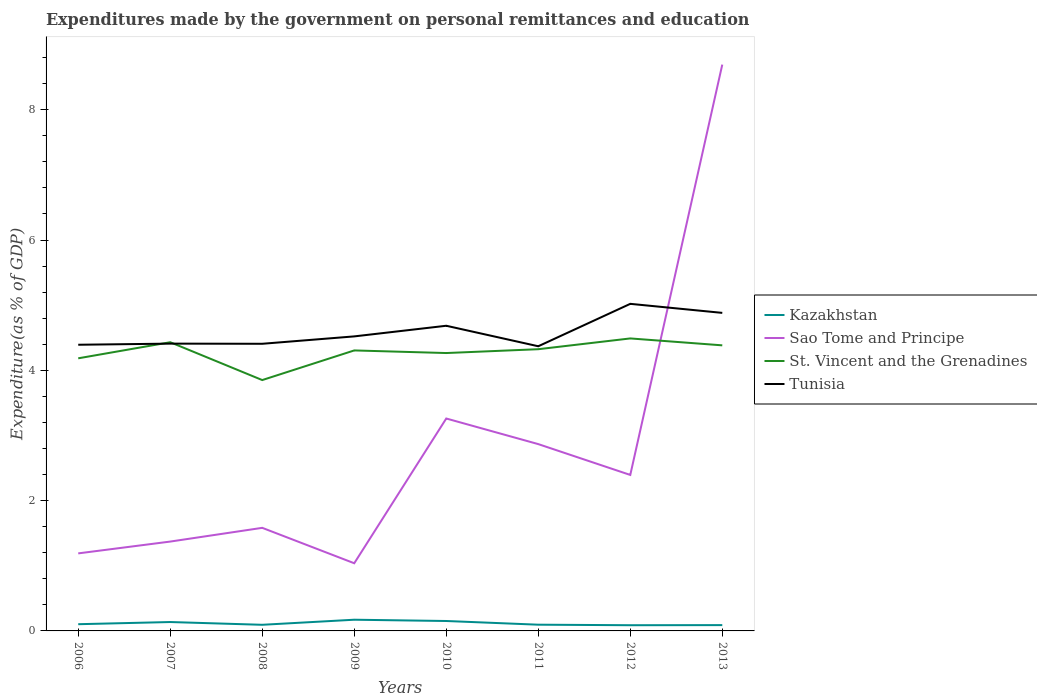How many different coloured lines are there?
Your answer should be very brief. 4. Does the line corresponding to Tunisia intersect with the line corresponding to Sao Tome and Principe?
Your response must be concise. Yes. Across all years, what is the maximum expenditures made by the government on personal remittances and education in Kazakhstan?
Ensure brevity in your answer.  0.09. In which year was the expenditures made by the government on personal remittances and education in St. Vincent and the Grenadines maximum?
Ensure brevity in your answer.  2008. What is the total expenditures made by the government on personal remittances and education in Kazakhstan in the graph?
Your answer should be compact. 0.04. What is the difference between the highest and the second highest expenditures made by the government on personal remittances and education in Kazakhstan?
Ensure brevity in your answer.  0.08. Is the expenditures made by the government on personal remittances and education in Tunisia strictly greater than the expenditures made by the government on personal remittances and education in Sao Tome and Principe over the years?
Ensure brevity in your answer.  No. How many lines are there?
Your response must be concise. 4. What is the difference between two consecutive major ticks on the Y-axis?
Keep it short and to the point. 2. Does the graph contain grids?
Provide a short and direct response. No. How many legend labels are there?
Your answer should be very brief. 4. How are the legend labels stacked?
Ensure brevity in your answer.  Vertical. What is the title of the graph?
Provide a short and direct response. Expenditures made by the government on personal remittances and education. Does "Namibia" appear as one of the legend labels in the graph?
Keep it short and to the point. No. What is the label or title of the X-axis?
Your answer should be very brief. Years. What is the label or title of the Y-axis?
Provide a succinct answer. Expenditure(as % of GDP). What is the Expenditure(as % of GDP) in Kazakhstan in 2006?
Offer a very short reply. 0.1. What is the Expenditure(as % of GDP) in Sao Tome and Principe in 2006?
Provide a succinct answer. 1.19. What is the Expenditure(as % of GDP) of St. Vincent and the Grenadines in 2006?
Give a very brief answer. 4.18. What is the Expenditure(as % of GDP) in Tunisia in 2006?
Make the answer very short. 4.39. What is the Expenditure(as % of GDP) of Kazakhstan in 2007?
Your response must be concise. 0.14. What is the Expenditure(as % of GDP) in Sao Tome and Principe in 2007?
Offer a terse response. 1.37. What is the Expenditure(as % of GDP) of St. Vincent and the Grenadines in 2007?
Your response must be concise. 4.43. What is the Expenditure(as % of GDP) of Tunisia in 2007?
Provide a succinct answer. 4.41. What is the Expenditure(as % of GDP) in Kazakhstan in 2008?
Your response must be concise. 0.09. What is the Expenditure(as % of GDP) in Sao Tome and Principe in 2008?
Offer a terse response. 1.58. What is the Expenditure(as % of GDP) in St. Vincent and the Grenadines in 2008?
Your answer should be compact. 3.85. What is the Expenditure(as % of GDP) in Tunisia in 2008?
Make the answer very short. 4.41. What is the Expenditure(as % of GDP) of Kazakhstan in 2009?
Your response must be concise. 0.17. What is the Expenditure(as % of GDP) of Sao Tome and Principe in 2009?
Give a very brief answer. 1.04. What is the Expenditure(as % of GDP) of St. Vincent and the Grenadines in 2009?
Offer a very short reply. 4.31. What is the Expenditure(as % of GDP) of Tunisia in 2009?
Give a very brief answer. 4.52. What is the Expenditure(as % of GDP) in Kazakhstan in 2010?
Your answer should be compact. 0.15. What is the Expenditure(as % of GDP) of Sao Tome and Principe in 2010?
Offer a very short reply. 3.26. What is the Expenditure(as % of GDP) in St. Vincent and the Grenadines in 2010?
Offer a very short reply. 4.27. What is the Expenditure(as % of GDP) in Tunisia in 2010?
Your answer should be very brief. 4.68. What is the Expenditure(as % of GDP) in Kazakhstan in 2011?
Keep it short and to the point. 0.1. What is the Expenditure(as % of GDP) in Sao Tome and Principe in 2011?
Your answer should be compact. 2.87. What is the Expenditure(as % of GDP) in St. Vincent and the Grenadines in 2011?
Your response must be concise. 4.32. What is the Expenditure(as % of GDP) in Tunisia in 2011?
Make the answer very short. 4.37. What is the Expenditure(as % of GDP) of Kazakhstan in 2012?
Provide a succinct answer. 0.09. What is the Expenditure(as % of GDP) of Sao Tome and Principe in 2012?
Keep it short and to the point. 2.39. What is the Expenditure(as % of GDP) in St. Vincent and the Grenadines in 2012?
Provide a succinct answer. 4.49. What is the Expenditure(as % of GDP) of Tunisia in 2012?
Offer a terse response. 5.02. What is the Expenditure(as % of GDP) of Kazakhstan in 2013?
Give a very brief answer. 0.09. What is the Expenditure(as % of GDP) of Sao Tome and Principe in 2013?
Your response must be concise. 8.69. What is the Expenditure(as % of GDP) of St. Vincent and the Grenadines in 2013?
Offer a very short reply. 4.38. What is the Expenditure(as % of GDP) in Tunisia in 2013?
Your answer should be very brief. 4.88. Across all years, what is the maximum Expenditure(as % of GDP) in Kazakhstan?
Your answer should be compact. 0.17. Across all years, what is the maximum Expenditure(as % of GDP) of Sao Tome and Principe?
Your answer should be very brief. 8.69. Across all years, what is the maximum Expenditure(as % of GDP) in St. Vincent and the Grenadines?
Make the answer very short. 4.49. Across all years, what is the maximum Expenditure(as % of GDP) in Tunisia?
Make the answer very short. 5.02. Across all years, what is the minimum Expenditure(as % of GDP) of Kazakhstan?
Keep it short and to the point. 0.09. Across all years, what is the minimum Expenditure(as % of GDP) in Sao Tome and Principe?
Your answer should be very brief. 1.04. Across all years, what is the minimum Expenditure(as % of GDP) in St. Vincent and the Grenadines?
Provide a short and direct response. 3.85. Across all years, what is the minimum Expenditure(as % of GDP) of Tunisia?
Your answer should be compact. 4.37. What is the total Expenditure(as % of GDP) of Kazakhstan in the graph?
Make the answer very short. 0.93. What is the total Expenditure(as % of GDP) in Sao Tome and Principe in the graph?
Ensure brevity in your answer.  22.4. What is the total Expenditure(as % of GDP) of St. Vincent and the Grenadines in the graph?
Keep it short and to the point. 34.23. What is the total Expenditure(as % of GDP) of Tunisia in the graph?
Your response must be concise. 36.69. What is the difference between the Expenditure(as % of GDP) in Kazakhstan in 2006 and that in 2007?
Your answer should be compact. -0.03. What is the difference between the Expenditure(as % of GDP) in Sao Tome and Principe in 2006 and that in 2007?
Provide a short and direct response. -0.18. What is the difference between the Expenditure(as % of GDP) in St. Vincent and the Grenadines in 2006 and that in 2007?
Keep it short and to the point. -0.25. What is the difference between the Expenditure(as % of GDP) in Tunisia in 2006 and that in 2007?
Offer a terse response. -0.02. What is the difference between the Expenditure(as % of GDP) of Kazakhstan in 2006 and that in 2008?
Ensure brevity in your answer.  0.01. What is the difference between the Expenditure(as % of GDP) in Sao Tome and Principe in 2006 and that in 2008?
Your response must be concise. -0.39. What is the difference between the Expenditure(as % of GDP) in St. Vincent and the Grenadines in 2006 and that in 2008?
Provide a short and direct response. 0.33. What is the difference between the Expenditure(as % of GDP) in Tunisia in 2006 and that in 2008?
Ensure brevity in your answer.  -0.01. What is the difference between the Expenditure(as % of GDP) of Kazakhstan in 2006 and that in 2009?
Your answer should be very brief. -0.07. What is the difference between the Expenditure(as % of GDP) of Sao Tome and Principe in 2006 and that in 2009?
Offer a terse response. 0.15. What is the difference between the Expenditure(as % of GDP) in St. Vincent and the Grenadines in 2006 and that in 2009?
Give a very brief answer. -0.12. What is the difference between the Expenditure(as % of GDP) of Tunisia in 2006 and that in 2009?
Offer a terse response. -0.13. What is the difference between the Expenditure(as % of GDP) of Kazakhstan in 2006 and that in 2010?
Provide a short and direct response. -0.05. What is the difference between the Expenditure(as % of GDP) of Sao Tome and Principe in 2006 and that in 2010?
Ensure brevity in your answer.  -2.07. What is the difference between the Expenditure(as % of GDP) of St. Vincent and the Grenadines in 2006 and that in 2010?
Your answer should be very brief. -0.08. What is the difference between the Expenditure(as % of GDP) of Tunisia in 2006 and that in 2010?
Ensure brevity in your answer.  -0.29. What is the difference between the Expenditure(as % of GDP) of Kazakhstan in 2006 and that in 2011?
Your response must be concise. 0.01. What is the difference between the Expenditure(as % of GDP) of Sao Tome and Principe in 2006 and that in 2011?
Give a very brief answer. -1.68. What is the difference between the Expenditure(as % of GDP) of St. Vincent and the Grenadines in 2006 and that in 2011?
Provide a succinct answer. -0.14. What is the difference between the Expenditure(as % of GDP) in Tunisia in 2006 and that in 2011?
Make the answer very short. 0.02. What is the difference between the Expenditure(as % of GDP) of Kazakhstan in 2006 and that in 2012?
Ensure brevity in your answer.  0.02. What is the difference between the Expenditure(as % of GDP) of Sao Tome and Principe in 2006 and that in 2012?
Offer a terse response. -1.2. What is the difference between the Expenditure(as % of GDP) of St. Vincent and the Grenadines in 2006 and that in 2012?
Your response must be concise. -0.31. What is the difference between the Expenditure(as % of GDP) in Tunisia in 2006 and that in 2012?
Provide a succinct answer. -0.63. What is the difference between the Expenditure(as % of GDP) of Kazakhstan in 2006 and that in 2013?
Ensure brevity in your answer.  0.01. What is the difference between the Expenditure(as % of GDP) in Sao Tome and Principe in 2006 and that in 2013?
Offer a terse response. -7.5. What is the difference between the Expenditure(as % of GDP) of St. Vincent and the Grenadines in 2006 and that in 2013?
Make the answer very short. -0.2. What is the difference between the Expenditure(as % of GDP) in Tunisia in 2006 and that in 2013?
Make the answer very short. -0.49. What is the difference between the Expenditure(as % of GDP) of Kazakhstan in 2007 and that in 2008?
Your answer should be compact. 0.04. What is the difference between the Expenditure(as % of GDP) in Sao Tome and Principe in 2007 and that in 2008?
Offer a very short reply. -0.21. What is the difference between the Expenditure(as % of GDP) of St. Vincent and the Grenadines in 2007 and that in 2008?
Make the answer very short. 0.58. What is the difference between the Expenditure(as % of GDP) in Tunisia in 2007 and that in 2008?
Offer a terse response. 0. What is the difference between the Expenditure(as % of GDP) of Kazakhstan in 2007 and that in 2009?
Offer a very short reply. -0.04. What is the difference between the Expenditure(as % of GDP) in Sao Tome and Principe in 2007 and that in 2009?
Provide a succinct answer. 0.33. What is the difference between the Expenditure(as % of GDP) of St. Vincent and the Grenadines in 2007 and that in 2009?
Ensure brevity in your answer.  0.13. What is the difference between the Expenditure(as % of GDP) in Tunisia in 2007 and that in 2009?
Keep it short and to the point. -0.11. What is the difference between the Expenditure(as % of GDP) in Kazakhstan in 2007 and that in 2010?
Offer a very short reply. -0.02. What is the difference between the Expenditure(as % of GDP) in Sao Tome and Principe in 2007 and that in 2010?
Provide a short and direct response. -1.89. What is the difference between the Expenditure(as % of GDP) in St. Vincent and the Grenadines in 2007 and that in 2010?
Offer a very short reply. 0.17. What is the difference between the Expenditure(as % of GDP) of Tunisia in 2007 and that in 2010?
Offer a very short reply. -0.27. What is the difference between the Expenditure(as % of GDP) in Kazakhstan in 2007 and that in 2011?
Your answer should be very brief. 0.04. What is the difference between the Expenditure(as % of GDP) in Sao Tome and Principe in 2007 and that in 2011?
Provide a succinct answer. -1.5. What is the difference between the Expenditure(as % of GDP) in St. Vincent and the Grenadines in 2007 and that in 2011?
Keep it short and to the point. 0.11. What is the difference between the Expenditure(as % of GDP) in Tunisia in 2007 and that in 2011?
Offer a terse response. 0.04. What is the difference between the Expenditure(as % of GDP) of Kazakhstan in 2007 and that in 2012?
Offer a terse response. 0.05. What is the difference between the Expenditure(as % of GDP) in Sao Tome and Principe in 2007 and that in 2012?
Your answer should be compact. -1.02. What is the difference between the Expenditure(as % of GDP) of St. Vincent and the Grenadines in 2007 and that in 2012?
Offer a terse response. -0.06. What is the difference between the Expenditure(as % of GDP) in Tunisia in 2007 and that in 2012?
Offer a very short reply. -0.61. What is the difference between the Expenditure(as % of GDP) in Kazakhstan in 2007 and that in 2013?
Provide a short and direct response. 0.05. What is the difference between the Expenditure(as % of GDP) of Sao Tome and Principe in 2007 and that in 2013?
Provide a short and direct response. -7.32. What is the difference between the Expenditure(as % of GDP) of St. Vincent and the Grenadines in 2007 and that in 2013?
Keep it short and to the point. 0.05. What is the difference between the Expenditure(as % of GDP) in Tunisia in 2007 and that in 2013?
Give a very brief answer. -0.47. What is the difference between the Expenditure(as % of GDP) in Kazakhstan in 2008 and that in 2009?
Your response must be concise. -0.08. What is the difference between the Expenditure(as % of GDP) in Sao Tome and Principe in 2008 and that in 2009?
Offer a terse response. 0.54. What is the difference between the Expenditure(as % of GDP) in St. Vincent and the Grenadines in 2008 and that in 2009?
Ensure brevity in your answer.  -0.45. What is the difference between the Expenditure(as % of GDP) of Tunisia in 2008 and that in 2009?
Ensure brevity in your answer.  -0.11. What is the difference between the Expenditure(as % of GDP) in Kazakhstan in 2008 and that in 2010?
Make the answer very short. -0.06. What is the difference between the Expenditure(as % of GDP) in Sao Tome and Principe in 2008 and that in 2010?
Your answer should be compact. -1.68. What is the difference between the Expenditure(as % of GDP) in St. Vincent and the Grenadines in 2008 and that in 2010?
Your answer should be very brief. -0.41. What is the difference between the Expenditure(as % of GDP) of Tunisia in 2008 and that in 2010?
Ensure brevity in your answer.  -0.28. What is the difference between the Expenditure(as % of GDP) in Kazakhstan in 2008 and that in 2011?
Your answer should be very brief. -0. What is the difference between the Expenditure(as % of GDP) in Sao Tome and Principe in 2008 and that in 2011?
Provide a succinct answer. -1.29. What is the difference between the Expenditure(as % of GDP) in St. Vincent and the Grenadines in 2008 and that in 2011?
Give a very brief answer. -0.47. What is the difference between the Expenditure(as % of GDP) of Tunisia in 2008 and that in 2011?
Provide a short and direct response. 0.04. What is the difference between the Expenditure(as % of GDP) in Kazakhstan in 2008 and that in 2012?
Ensure brevity in your answer.  0.01. What is the difference between the Expenditure(as % of GDP) of Sao Tome and Principe in 2008 and that in 2012?
Give a very brief answer. -0.81. What is the difference between the Expenditure(as % of GDP) in St. Vincent and the Grenadines in 2008 and that in 2012?
Provide a succinct answer. -0.64. What is the difference between the Expenditure(as % of GDP) in Tunisia in 2008 and that in 2012?
Your answer should be compact. -0.61. What is the difference between the Expenditure(as % of GDP) of Kazakhstan in 2008 and that in 2013?
Your answer should be compact. 0. What is the difference between the Expenditure(as % of GDP) of Sao Tome and Principe in 2008 and that in 2013?
Offer a terse response. -7.11. What is the difference between the Expenditure(as % of GDP) in St. Vincent and the Grenadines in 2008 and that in 2013?
Offer a very short reply. -0.53. What is the difference between the Expenditure(as % of GDP) of Tunisia in 2008 and that in 2013?
Offer a very short reply. -0.47. What is the difference between the Expenditure(as % of GDP) in Kazakhstan in 2009 and that in 2010?
Ensure brevity in your answer.  0.02. What is the difference between the Expenditure(as % of GDP) of Sao Tome and Principe in 2009 and that in 2010?
Your answer should be compact. -2.22. What is the difference between the Expenditure(as % of GDP) in St. Vincent and the Grenadines in 2009 and that in 2010?
Provide a succinct answer. 0.04. What is the difference between the Expenditure(as % of GDP) in Tunisia in 2009 and that in 2010?
Offer a terse response. -0.16. What is the difference between the Expenditure(as % of GDP) in Kazakhstan in 2009 and that in 2011?
Keep it short and to the point. 0.08. What is the difference between the Expenditure(as % of GDP) of Sao Tome and Principe in 2009 and that in 2011?
Your response must be concise. -1.83. What is the difference between the Expenditure(as % of GDP) in St. Vincent and the Grenadines in 2009 and that in 2011?
Offer a terse response. -0.02. What is the difference between the Expenditure(as % of GDP) in Tunisia in 2009 and that in 2011?
Provide a short and direct response. 0.15. What is the difference between the Expenditure(as % of GDP) of Kazakhstan in 2009 and that in 2012?
Provide a short and direct response. 0.08. What is the difference between the Expenditure(as % of GDP) of Sao Tome and Principe in 2009 and that in 2012?
Provide a succinct answer. -1.36. What is the difference between the Expenditure(as % of GDP) in St. Vincent and the Grenadines in 2009 and that in 2012?
Keep it short and to the point. -0.18. What is the difference between the Expenditure(as % of GDP) of Tunisia in 2009 and that in 2012?
Provide a short and direct response. -0.5. What is the difference between the Expenditure(as % of GDP) of Kazakhstan in 2009 and that in 2013?
Keep it short and to the point. 0.08. What is the difference between the Expenditure(as % of GDP) of Sao Tome and Principe in 2009 and that in 2013?
Make the answer very short. -7.65. What is the difference between the Expenditure(as % of GDP) in St. Vincent and the Grenadines in 2009 and that in 2013?
Your answer should be compact. -0.08. What is the difference between the Expenditure(as % of GDP) in Tunisia in 2009 and that in 2013?
Provide a short and direct response. -0.36. What is the difference between the Expenditure(as % of GDP) of Kazakhstan in 2010 and that in 2011?
Provide a short and direct response. 0.06. What is the difference between the Expenditure(as % of GDP) in Sao Tome and Principe in 2010 and that in 2011?
Offer a terse response. 0.39. What is the difference between the Expenditure(as % of GDP) of St. Vincent and the Grenadines in 2010 and that in 2011?
Ensure brevity in your answer.  -0.06. What is the difference between the Expenditure(as % of GDP) of Tunisia in 2010 and that in 2011?
Your response must be concise. 0.31. What is the difference between the Expenditure(as % of GDP) of Kazakhstan in 2010 and that in 2012?
Offer a very short reply. 0.06. What is the difference between the Expenditure(as % of GDP) in Sao Tome and Principe in 2010 and that in 2012?
Your answer should be compact. 0.87. What is the difference between the Expenditure(as % of GDP) of St. Vincent and the Grenadines in 2010 and that in 2012?
Offer a very short reply. -0.22. What is the difference between the Expenditure(as % of GDP) of Tunisia in 2010 and that in 2012?
Your answer should be very brief. -0.34. What is the difference between the Expenditure(as % of GDP) in Kazakhstan in 2010 and that in 2013?
Offer a terse response. 0.06. What is the difference between the Expenditure(as % of GDP) in Sao Tome and Principe in 2010 and that in 2013?
Provide a succinct answer. -5.43. What is the difference between the Expenditure(as % of GDP) in St. Vincent and the Grenadines in 2010 and that in 2013?
Offer a very short reply. -0.12. What is the difference between the Expenditure(as % of GDP) of Tunisia in 2010 and that in 2013?
Offer a terse response. -0.2. What is the difference between the Expenditure(as % of GDP) of Kazakhstan in 2011 and that in 2012?
Make the answer very short. 0.01. What is the difference between the Expenditure(as % of GDP) in Sao Tome and Principe in 2011 and that in 2012?
Offer a terse response. 0.47. What is the difference between the Expenditure(as % of GDP) of St. Vincent and the Grenadines in 2011 and that in 2012?
Your answer should be compact. -0.17. What is the difference between the Expenditure(as % of GDP) of Tunisia in 2011 and that in 2012?
Keep it short and to the point. -0.65. What is the difference between the Expenditure(as % of GDP) of Kazakhstan in 2011 and that in 2013?
Ensure brevity in your answer.  0.01. What is the difference between the Expenditure(as % of GDP) of Sao Tome and Principe in 2011 and that in 2013?
Keep it short and to the point. -5.83. What is the difference between the Expenditure(as % of GDP) in St. Vincent and the Grenadines in 2011 and that in 2013?
Give a very brief answer. -0.06. What is the difference between the Expenditure(as % of GDP) in Tunisia in 2011 and that in 2013?
Provide a short and direct response. -0.51. What is the difference between the Expenditure(as % of GDP) in Kazakhstan in 2012 and that in 2013?
Make the answer very short. -0. What is the difference between the Expenditure(as % of GDP) in Sao Tome and Principe in 2012 and that in 2013?
Your answer should be very brief. -6.3. What is the difference between the Expenditure(as % of GDP) in St. Vincent and the Grenadines in 2012 and that in 2013?
Offer a terse response. 0.11. What is the difference between the Expenditure(as % of GDP) in Tunisia in 2012 and that in 2013?
Your answer should be compact. 0.14. What is the difference between the Expenditure(as % of GDP) of Kazakhstan in 2006 and the Expenditure(as % of GDP) of Sao Tome and Principe in 2007?
Provide a short and direct response. -1.27. What is the difference between the Expenditure(as % of GDP) of Kazakhstan in 2006 and the Expenditure(as % of GDP) of St. Vincent and the Grenadines in 2007?
Give a very brief answer. -4.33. What is the difference between the Expenditure(as % of GDP) of Kazakhstan in 2006 and the Expenditure(as % of GDP) of Tunisia in 2007?
Provide a succinct answer. -4.31. What is the difference between the Expenditure(as % of GDP) of Sao Tome and Principe in 2006 and the Expenditure(as % of GDP) of St. Vincent and the Grenadines in 2007?
Provide a short and direct response. -3.24. What is the difference between the Expenditure(as % of GDP) of Sao Tome and Principe in 2006 and the Expenditure(as % of GDP) of Tunisia in 2007?
Provide a short and direct response. -3.22. What is the difference between the Expenditure(as % of GDP) of St. Vincent and the Grenadines in 2006 and the Expenditure(as % of GDP) of Tunisia in 2007?
Provide a short and direct response. -0.23. What is the difference between the Expenditure(as % of GDP) of Kazakhstan in 2006 and the Expenditure(as % of GDP) of Sao Tome and Principe in 2008?
Your response must be concise. -1.48. What is the difference between the Expenditure(as % of GDP) in Kazakhstan in 2006 and the Expenditure(as % of GDP) in St. Vincent and the Grenadines in 2008?
Your answer should be compact. -3.75. What is the difference between the Expenditure(as % of GDP) in Kazakhstan in 2006 and the Expenditure(as % of GDP) in Tunisia in 2008?
Provide a short and direct response. -4.3. What is the difference between the Expenditure(as % of GDP) of Sao Tome and Principe in 2006 and the Expenditure(as % of GDP) of St. Vincent and the Grenadines in 2008?
Ensure brevity in your answer.  -2.66. What is the difference between the Expenditure(as % of GDP) in Sao Tome and Principe in 2006 and the Expenditure(as % of GDP) in Tunisia in 2008?
Provide a succinct answer. -3.22. What is the difference between the Expenditure(as % of GDP) in St. Vincent and the Grenadines in 2006 and the Expenditure(as % of GDP) in Tunisia in 2008?
Give a very brief answer. -0.22. What is the difference between the Expenditure(as % of GDP) of Kazakhstan in 2006 and the Expenditure(as % of GDP) of Sao Tome and Principe in 2009?
Give a very brief answer. -0.94. What is the difference between the Expenditure(as % of GDP) of Kazakhstan in 2006 and the Expenditure(as % of GDP) of St. Vincent and the Grenadines in 2009?
Ensure brevity in your answer.  -4.2. What is the difference between the Expenditure(as % of GDP) of Kazakhstan in 2006 and the Expenditure(as % of GDP) of Tunisia in 2009?
Provide a succinct answer. -4.42. What is the difference between the Expenditure(as % of GDP) in Sao Tome and Principe in 2006 and the Expenditure(as % of GDP) in St. Vincent and the Grenadines in 2009?
Your answer should be very brief. -3.12. What is the difference between the Expenditure(as % of GDP) in Sao Tome and Principe in 2006 and the Expenditure(as % of GDP) in Tunisia in 2009?
Offer a very short reply. -3.33. What is the difference between the Expenditure(as % of GDP) in St. Vincent and the Grenadines in 2006 and the Expenditure(as % of GDP) in Tunisia in 2009?
Your response must be concise. -0.34. What is the difference between the Expenditure(as % of GDP) in Kazakhstan in 2006 and the Expenditure(as % of GDP) in Sao Tome and Principe in 2010?
Offer a terse response. -3.16. What is the difference between the Expenditure(as % of GDP) of Kazakhstan in 2006 and the Expenditure(as % of GDP) of St. Vincent and the Grenadines in 2010?
Make the answer very short. -4.16. What is the difference between the Expenditure(as % of GDP) in Kazakhstan in 2006 and the Expenditure(as % of GDP) in Tunisia in 2010?
Your answer should be compact. -4.58. What is the difference between the Expenditure(as % of GDP) in Sao Tome and Principe in 2006 and the Expenditure(as % of GDP) in St. Vincent and the Grenadines in 2010?
Keep it short and to the point. -3.08. What is the difference between the Expenditure(as % of GDP) of Sao Tome and Principe in 2006 and the Expenditure(as % of GDP) of Tunisia in 2010?
Make the answer very short. -3.49. What is the difference between the Expenditure(as % of GDP) in St. Vincent and the Grenadines in 2006 and the Expenditure(as % of GDP) in Tunisia in 2010?
Give a very brief answer. -0.5. What is the difference between the Expenditure(as % of GDP) in Kazakhstan in 2006 and the Expenditure(as % of GDP) in Sao Tome and Principe in 2011?
Offer a very short reply. -2.76. What is the difference between the Expenditure(as % of GDP) of Kazakhstan in 2006 and the Expenditure(as % of GDP) of St. Vincent and the Grenadines in 2011?
Your response must be concise. -4.22. What is the difference between the Expenditure(as % of GDP) of Kazakhstan in 2006 and the Expenditure(as % of GDP) of Tunisia in 2011?
Your response must be concise. -4.27. What is the difference between the Expenditure(as % of GDP) in Sao Tome and Principe in 2006 and the Expenditure(as % of GDP) in St. Vincent and the Grenadines in 2011?
Offer a terse response. -3.13. What is the difference between the Expenditure(as % of GDP) in Sao Tome and Principe in 2006 and the Expenditure(as % of GDP) in Tunisia in 2011?
Give a very brief answer. -3.18. What is the difference between the Expenditure(as % of GDP) of St. Vincent and the Grenadines in 2006 and the Expenditure(as % of GDP) of Tunisia in 2011?
Make the answer very short. -0.18. What is the difference between the Expenditure(as % of GDP) in Kazakhstan in 2006 and the Expenditure(as % of GDP) in Sao Tome and Principe in 2012?
Provide a short and direct response. -2.29. What is the difference between the Expenditure(as % of GDP) of Kazakhstan in 2006 and the Expenditure(as % of GDP) of St. Vincent and the Grenadines in 2012?
Your response must be concise. -4.39. What is the difference between the Expenditure(as % of GDP) in Kazakhstan in 2006 and the Expenditure(as % of GDP) in Tunisia in 2012?
Provide a succinct answer. -4.92. What is the difference between the Expenditure(as % of GDP) of Sao Tome and Principe in 2006 and the Expenditure(as % of GDP) of St. Vincent and the Grenadines in 2012?
Your answer should be compact. -3.3. What is the difference between the Expenditure(as % of GDP) of Sao Tome and Principe in 2006 and the Expenditure(as % of GDP) of Tunisia in 2012?
Ensure brevity in your answer.  -3.83. What is the difference between the Expenditure(as % of GDP) in St. Vincent and the Grenadines in 2006 and the Expenditure(as % of GDP) in Tunisia in 2012?
Ensure brevity in your answer.  -0.84. What is the difference between the Expenditure(as % of GDP) in Kazakhstan in 2006 and the Expenditure(as % of GDP) in Sao Tome and Principe in 2013?
Give a very brief answer. -8.59. What is the difference between the Expenditure(as % of GDP) of Kazakhstan in 2006 and the Expenditure(as % of GDP) of St. Vincent and the Grenadines in 2013?
Make the answer very short. -4.28. What is the difference between the Expenditure(as % of GDP) of Kazakhstan in 2006 and the Expenditure(as % of GDP) of Tunisia in 2013?
Your answer should be very brief. -4.78. What is the difference between the Expenditure(as % of GDP) in Sao Tome and Principe in 2006 and the Expenditure(as % of GDP) in St. Vincent and the Grenadines in 2013?
Ensure brevity in your answer.  -3.19. What is the difference between the Expenditure(as % of GDP) in Sao Tome and Principe in 2006 and the Expenditure(as % of GDP) in Tunisia in 2013?
Make the answer very short. -3.69. What is the difference between the Expenditure(as % of GDP) in St. Vincent and the Grenadines in 2006 and the Expenditure(as % of GDP) in Tunisia in 2013?
Offer a very short reply. -0.7. What is the difference between the Expenditure(as % of GDP) in Kazakhstan in 2007 and the Expenditure(as % of GDP) in Sao Tome and Principe in 2008?
Your answer should be very brief. -1.45. What is the difference between the Expenditure(as % of GDP) in Kazakhstan in 2007 and the Expenditure(as % of GDP) in St. Vincent and the Grenadines in 2008?
Make the answer very short. -3.71. What is the difference between the Expenditure(as % of GDP) of Kazakhstan in 2007 and the Expenditure(as % of GDP) of Tunisia in 2008?
Provide a succinct answer. -4.27. What is the difference between the Expenditure(as % of GDP) in Sao Tome and Principe in 2007 and the Expenditure(as % of GDP) in St. Vincent and the Grenadines in 2008?
Offer a terse response. -2.48. What is the difference between the Expenditure(as % of GDP) in Sao Tome and Principe in 2007 and the Expenditure(as % of GDP) in Tunisia in 2008?
Provide a short and direct response. -3.04. What is the difference between the Expenditure(as % of GDP) of St. Vincent and the Grenadines in 2007 and the Expenditure(as % of GDP) of Tunisia in 2008?
Give a very brief answer. 0.02. What is the difference between the Expenditure(as % of GDP) of Kazakhstan in 2007 and the Expenditure(as % of GDP) of Sao Tome and Principe in 2009?
Offer a very short reply. -0.9. What is the difference between the Expenditure(as % of GDP) of Kazakhstan in 2007 and the Expenditure(as % of GDP) of St. Vincent and the Grenadines in 2009?
Provide a succinct answer. -4.17. What is the difference between the Expenditure(as % of GDP) in Kazakhstan in 2007 and the Expenditure(as % of GDP) in Tunisia in 2009?
Provide a short and direct response. -4.38. What is the difference between the Expenditure(as % of GDP) in Sao Tome and Principe in 2007 and the Expenditure(as % of GDP) in St. Vincent and the Grenadines in 2009?
Ensure brevity in your answer.  -2.93. What is the difference between the Expenditure(as % of GDP) of Sao Tome and Principe in 2007 and the Expenditure(as % of GDP) of Tunisia in 2009?
Make the answer very short. -3.15. What is the difference between the Expenditure(as % of GDP) of St. Vincent and the Grenadines in 2007 and the Expenditure(as % of GDP) of Tunisia in 2009?
Ensure brevity in your answer.  -0.09. What is the difference between the Expenditure(as % of GDP) of Kazakhstan in 2007 and the Expenditure(as % of GDP) of Sao Tome and Principe in 2010?
Give a very brief answer. -3.12. What is the difference between the Expenditure(as % of GDP) of Kazakhstan in 2007 and the Expenditure(as % of GDP) of St. Vincent and the Grenadines in 2010?
Your answer should be compact. -4.13. What is the difference between the Expenditure(as % of GDP) of Kazakhstan in 2007 and the Expenditure(as % of GDP) of Tunisia in 2010?
Your answer should be very brief. -4.55. What is the difference between the Expenditure(as % of GDP) of Sao Tome and Principe in 2007 and the Expenditure(as % of GDP) of St. Vincent and the Grenadines in 2010?
Ensure brevity in your answer.  -2.89. What is the difference between the Expenditure(as % of GDP) of Sao Tome and Principe in 2007 and the Expenditure(as % of GDP) of Tunisia in 2010?
Offer a terse response. -3.31. What is the difference between the Expenditure(as % of GDP) in St. Vincent and the Grenadines in 2007 and the Expenditure(as % of GDP) in Tunisia in 2010?
Ensure brevity in your answer.  -0.25. What is the difference between the Expenditure(as % of GDP) of Kazakhstan in 2007 and the Expenditure(as % of GDP) of Sao Tome and Principe in 2011?
Your response must be concise. -2.73. What is the difference between the Expenditure(as % of GDP) in Kazakhstan in 2007 and the Expenditure(as % of GDP) in St. Vincent and the Grenadines in 2011?
Provide a succinct answer. -4.19. What is the difference between the Expenditure(as % of GDP) in Kazakhstan in 2007 and the Expenditure(as % of GDP) in Tunisia in 2011?
Your response must be concise. -4.23. What is the difference between the Expenditure(as % of GDP) of Sao Tome and Principe in 2007 and the Expenditure(as % of GDP) of St. Vincent and the Grenadines in 2011?
Your answer should be compact. -2.95. What is the difference between the Expenditure(as % of GDP) in Sao Tome and Principe in 2007 and the Expenditure(as % of GDP) in Tunisia in 2011?
Offer a very short reply. -3. What is the difference between the Expenditure(as % of GDP) in St. Vincent and the Grenadines in 2007 and the Expenditure(as % of GDP) in Tunisia in 2011?
Make the answer very short. 0.06. What is the difference between the Expenditure(as % of GDP) in Kazakhstan in 2007 and the Expenditure(as % of GDP) in Sao Tome and Principe in 2012?
Provide a short and direct response. -2.26. What is the difference between the Expenditure(as % of GDP) of Kazakhstan in 2007 and the Expenditure(as % of GDP) of St. Vincent and the Grenadines in 2012?
Provide a short and direct response. -4.35. What is the difference between the Expenditure(as % of GDP) in Kazakhstan in 2007 and the Expenditure(as % of GDP) in Tunisia in 2012?
Your answer should be very brief. -4.88. What is the difference between the Expenditure(as % of GDP) in Sao Tome and Principe in 2007 and the Expenditure(as % of GDP) in St. Vincent and the Grenadines in 2012?
Your answer should be very brief. -3.12. What is the difference between the Expenditure(as % of GDP) of Sao Tome and Principe in 2007 and the Expenditure(as % of GDP) of Tunisia in 2012?
Offer a very short reply. -3.65. What is the difference between the Expenditure(as % of GDP) in St. Vincent and the Grenadines in 2007 and the Expenditure(as % of GDP) in Tunisia in 2012?
Offer a very short reply. -0.59. What is the difference between the Expenditure(as % of GDP) in Kazakhstan in 2007 and the Expenditure(as % of GDP) in Sao Tome and Principe in 2013?
Your response must be concise. -8.56. What is the difference between the Expenditure(as % of GDP) in Kazakhstan in 2007 and the Expenditure(as % of GDP) in St. Vincent and the Grenadines in 2013?
Provide a succinct answer. -4.25. What is the difference between the Expenditure(as % of GDP) of Kazakhstan in 2007 and the Expenditure(as % of GDP) of Tunisia in 2013?
Your answer should be very brief. -4.75. What is the difference between the Expenditure(as % of GDP) in Sao Tome and Principe in 2007 and the Expenditure(as % of GDP) in St. Vincent and the Grenadines in 2013?
Offer a very short reply. -3.01. What is the difference between the Expenditure(as % of GDP) of Sao Tome and Principe in 2007 and the Expenditure(as % of GDP) of Tunisia in 2013?
Give a very brief answer. -3.51. What is the difference between the Expenditure(as % of GDP) of St. Vincent and the Grenadines in 2007 and the Expenditure(as % of GDP) of Tunisia in 2013?
Ensure brevity in your answer.  -0.45. What is the difference between the Expenditure(as % of GDP) of Kazakhstan in 2008 and the Expenditure(as % of GDP) of Sao Tome and Principe in 2009?
Provide a short and direct response. -0.94. What is the difference between the Expenditure(as % of GDP) in Kazakhstan in 2008 and the Expenditure(as % of GDP) in St. Vincent and the Grenadines in 2009?
Provide a succinct answer. -4.21. What is the difference between the Expenditure(as % of GDP) of Kazakhstan in 2008 and the Expenditure(as % of GDP) of Tunisia in 2009?
Keep it short and to the point. -4.43. What is the difference between the Expenditure(as % of GDP) of Sao Tome and Principe in 2008 and the Expenditure(as % of GDP) of St. Vincent and the Grenadines in 2009?
Your answer should be compact. -2.72. What is the difference between the Expenditure(as % of GDP) of Sao Tome and Principe in 2008 and the Expenditure(as % of GDP) of Tunisia in 2009?
Your answer should be compact. -2.94. What is the difference between the Expenditure(as % of GDP) in St. Vincent and the Grenadines in 2008 and the Expenditure(as % of GDP) in Tunisia in 2009?
Your answer should be very brief. -0.67. What is the difference between the Expenditure(as % of GDP) in Kazakhstan in 2008 and the Expenditure(as % of GDP) in Sao Tome and Principe in 2010?
Keep it short and to the point. -3.17. What is the difference between the Expenditure(as % of GDP) of Kazakhstan in 2008 and the Expenditure(as % of GDP) of St. Vincent and the Grenadines in 2010?
Your response must be concise. -4.17. What is the difference between the Expenditure(as % of GDP) in Kazakhstan in 2008 and the Expenditure(as % of GDP) in Tunisia in 2010?
Offer a very short reply. -4.59. What is the difference between the Expenditure(as % of GDP) of Sao Tome and Principe in 2008 and the Expenditure(as % of GDP) of St. Vincent and the Grenadines in 2010?
Provide a succinct answer. -2.68. What is the difference between the Expenditure(as % of GDP) in Sao Tome and Principe in 2008 and the Expenditure(as % of GDP) in Tunisia in 2010?
Provide a succinct answer. -3.1. What is the difference between the Expenditure(as % of GDP) of St. Vincent and the Grenadines in 2008 and the Expenditure(as % of GDP) of Tunisia in 2010?
Provide a succinct answer. -0.83. What is the difference between the Expenditure(as % of GDP) in Kazakhstan in 2008 and the Expenditure(as % of GDP) in Sao Tome and Principe in 2011?
Ensure brevity in your answer.  -2.77. What is the difference between the Expenditure(as % of GDP) of Kazakhstan in 2008 and the Expenditure(as % of GDP) of St. Vincent and the Grenadines in 2011?
Offer a terse response. -4.23. What is the difference between the Expenditure(as % of GDP) of Kazakhstan in 2008 and the Expenditure(as % of GDP) of Tunisia in 2011?
Provide a succinct answer. -4.28. What is the difference between the Expenditure(as % of GDP) in Sao Tome and Principe in 2008 and the Expenditure(as % of GDP) in St. Vincent and the Grenadines in 2011?
Your answer should be very brief. -2.74. What is the difference between the Expenditure(as % of GDP) in Sao Tome and Principe in 2008 and the Expenditure(as % of GDP) in Tunisia in 2011?
Your response must be concise. -2.79. What is the difference between the Expenditure(as % of GDP) of St. Vincent and the Grenadines in 2008 and the Expenditure(as % of GDP) of Tunisia in 2011?
Your response must be concise. -0.52. What is the difference between the Expenditure(as % of GDP) in Kazakhstan in 2008 and the Expenditure(as % of GDP) in Sao Tome and Principe in 2012?
Your answer should be compact. -2.3. What is the difference between the Expenditure(as % of GDP) of Kazakhstan in 2008 and the Expenditure(as % of GDP) of St. Vincent and the Grenadines in 2012?
Give a very brief answer. -4.4. What is the difference between the Expenditure(as % of GDP) in Kazakhstan in 2008 and the Expenditure(as % of GDP) in Tunisia in 2012?
Give a very brief answer. -4.93. What is the difference between the Expenditure(as % of GDP) of Sao Tome and Principe in 2008 and the Expenditure(as % of GDP) of St. Vincent and the Grenadines in 2012?
Offer a very short reply. -2.91. What is the difference between the Expenditure(as % of GDP) in Sao Tome and Principe in 2008 and the Expenditure(as % of GDP) in Tunisia in 2012?
Your answer should be compact. -3.44. What is the difference between the Expenditure(as % of GDP) of St. Vincent and the Grenadines in 2008 and the Expenditure(as % of GDP) of Tunisia in 2012?
Your answer should be compact. -1.17. What is the difference between the Expenditure(as % of GDP) in Kazakhstan in 2008 and the Expenditure(as % of GDP) in Sao Tome and Principe in 2013?
Offer a terse response. -8.6. What is the difference between the Expenditure(as % of GDP) of Kazakhstan in 2008 and the Expenditure(as % of GDP) of St. Vincent and the Grenadines in 2013?
Ensure brevity in your answer.  -4.29. What is the difference between the Expenditure(as % of GDP) of Kazakhstan in 2008 and the Expenditure(as % of GDP) of Tunisia in 2013?
Offer a very short reply. -4.79. What is the difference between the Expenditure(as % of GDP) in Sao Tome and Principe in 2008 and the Expenditure(as % of GDP) in St. Vincent and the Grenadines in 2013?
Your answer should be very brief. -2.8. What is the difference between the Expenditure(as % of GDP) in Sao Tome and Principe in 2008 and the Expenditure(as % of GDP) in Tunisia in 2013?
Your answer should be compact. -3.3. What is the difference between the Expenditure(as % of GDP) of St. Vincent and the Grenadines in 2008 and the Expenditure(as % of GDP) of Tunisia in 2013?
Your response must be concise. -1.03. What is the difference between the Expenditure(as % of GDP) of Kazakhstan in 2009 and the Expenditure(as % of GDP) of Sao Tome and Principe in 2010?
Your answer should be very brief. -3.09. What is the difference between the Expenditure(as % of GDP) in Kazakhstan in 2009 and the Expenditure(as % of GDP) in St. Vincent and the Grenadines in 2010?
Provide a succinct answer. -4.09. What is the difference between the Expenditure(as % of GDP) in Kazakhstan in 2009 and the Expenditure(as % of GDP) in Tunisia in 2010?
Provide a succinct answer. -4.51. What is the difference between the Expenditure(as % of GDP) of Sao Tome and Principe in 2009 and the Expenditure(as % of GDP) of St. Vincent and the Grenadines in 2010?
Provide a short and direct response. -3.23. What is the difference between the Expenditure(as % of GDP) of Sao Tome and Principe in 2009 and the Expenditure(as % of GDP) of Tunisia in 2010?
Provide a short and direct response. -3.65. What is the difference between the Expenditure(as % of GDP) in St. Vincent and the Grenadines in 2009 and the Expenditure(as % of GDP) in Tunisia in 2010?
Ensure brevity in your answer.  -0.38. What is the difference between the Expenditure(as % of GDP) in Kazakhstan in 2009 and the Expenditure(as % of GDP) in Sao Tome and Principe in 2011?
Keep it short and to the point. -2.7. What is the difference between the Expenditure(as % of GDP) of Kazakhstan in 2009 and the Expenditure(as % of GDP) of St. Vincent and the Grenadines in 2011?
Ensure brevity in your answer.  -4.15. What is the difference between the Expenditure(as % of GDP) in Kazakhstan in 2009 and the Expenditure(as % of GDP) in Tunisia in 2011?
Offer a very short reply. -4.2. What is the difference between the Expenditure(as % of GDP) in Sao Tome and Principe in 2009 and the Expenditure(as % of GDP) in St. Vincent and the Grenadines in 2011?
Keep it short and to the point. -3.29. What is the difference between the Expenditure(as % of GDP) of Sao Tome and Principe in 2009 and the Expenditure(as % of GDP) of Tunisia in 2011?
Your answer should be very brief. -3.33. What is the difference between the Expenditure(as % of GDP) of St. Vincent and the Grenadines in 2009 and the Expenditure(as % of GDP) of Tunisia in 2011?
Offer a very short reply. -0.06. What is the difference between the Expenditure(as % of GDP) in Kazakhstan in 2009 and the Expenditure(as % of GDP) in Sao Tome and Principe in 2012?
Offer a very short reply. -2.22. What is the difference between the Expenditure(as % of GDP) in Kazakhstan in 2009 and the Expenditure(as % of GDP) in St. Vincent and the Grenadines in 2012?
Ensure brevity in your answer.  -4.32. What is the difference between the Expenditure(as % of GDP) of Kazakhstan in 2009 and the Expenditure(as % of GDP) of Tunisia in 2012?
Provide a succinct answer. -4.85. What is the difference between the Expenditure(as % of GDP) in Sao Tome and Principe in 2009 and the Expenditure(as % of GDP) in St. Vincent and the Grenadines in 2012?
Keep it short and to the point. -3.45. What is the difference between the Expenditure(as % of GDP) in Sao Tome and Principe in 2009 and the Expenditure(as % of GDP) in Tunisia in 2012?
Offer a very short reply. -3.98. What is the difference between the Expenditure(as % of GDP) of St. Vincent and the Grenadines in 2009 and the Expenditure(as % of GDP) of Tunisia in 2012?
Provide a succinct answer. -0.71. What is the difference between the Expenditure(as % of GDP) in Kazakhstan in 2009 and the Expenditure(as % of GDP) in Sao Tome and Principe in 2013?
Keep it short and to the point. -8.52. What is the difference between the Expenditure(as % of GDP) of Kazakhstan in 2009 and the Expenditure(as % of GDP) of St. Vincent and the Grenadines in 2013?
Ensure brevity in your answer.  -4.21. What is the difference between the Expenditure(as % of GDP) of Kazakhstan in 2009 and the Expenditure(as % of GDP) of Tunisia in 2013?
Provide a succinct answer. -4.71. What is the difference between the Expenditure(as % of GDP) in Sao Tome and Principe in 2009 and the Expenditure(as % of GDP) in St. Vincent and the Grenadines in 2013?
Ensure brevity in your answer.  -3.34. What is the difference between the Expenditure(as % of GDP) of Sao Tome and Principe in 2009 and the Expenditure(as % of GDP) of Tunisia in 2013?
Your response must be concise. -3.84. What is the difference between the Expenditure(as % of GDP) of St. Vincent and the Grenadines in 2009 and the Expenditure(as % of GDP) of Tunisia in 2013?
Make the answer very short. -0.58. What is the difference between the Expenditure(as % of GDP) of Kazakhstan in 2010 and the Expenditure(as % of GDP) of Sao Tome and Principe in 2011?
Provide a succinct answer. -2.71. What is the difference between the Expenditure(as % of GDP) in Kazakhstan in 2010 and the Expenditure(as % of GDP) in St. Vincent and the Grenadines in 2011?
Offer a terse response. -4.17. What is the difference between the Expenditure(as % of GDP) in Kazakhstan in 2010 and the Expenditure(as % of GDP) in Tunisia in 2011?
Offer a very short reply. -4.22. What is the difference between the Expenditure(as % of GDP) of Sao Tome and Principe in 2010 and the Expenditure(as % of GDP) of St. Vincent and the Grenadines in 2011?
Your response must be concise. -1.06. What is the difference between the Expenditure(as % of GDP) in Sao Tome and Principe in 2010 and the Expenditure(as % of GDP) in Tunisia in 2011?
Offer a terse response. -1.11. What is the difference between the Expenditure(as % of GDP) of St. Vincent and the Grenadines in 2010 and the Expenditure(as % of GDP) of Tunisia in 2011?
Give a very brief answer. -0.1. What is the difference between the Expenditure(as % of GDP) in Kazakhstan in 2010 and the Expenditure(as % of GDP) in Sao Tome and Principe in 2012?
Your answer should be compact. -2.24. What is the difference between the Expenditure(as % of GDP) in Kazakhstan in 2010 and the Expenditure(as % of GDP) in St. Vincent and the Grenadines in 2012?
Provide a succinct answer. -4.34. What is the difference between the Expenditure(as % of GDP) of Kazakhstan in 2010 and the Expenditure(as % of GDP) of Tunisia in 2012?
Your answer should be compact. -4.87. What is the difference between the Expenditure(as % of GDP) in Sao Tome and Principe in 2010 and the Expenditure(as % of GDP) in St. Vincent and the Grenadines in 2012?
Offer a terse response. -1.23. What is the difference between the Expenditure(as % of GDP) of Sao Tome and Principe in 2010 and the Expenditure(as % of GDP) of Tunisia in 2012?
Keep it short and to the point. -1.76. What is the difference between the Expenditure(as % of GDP) in St. Vincent and the Grenadines in 2010 and the Expenditure(as % of GDP) in Tunisia in 2012?
Give a very brief answer. -0.76. What is the difference between the Expenditure(as % of GDP) of Kazakhstan in 2010 and the Expenditure(as % of GDP) of Sao Tome and Principe in 2013?
Offer a terse response. -8.54. What is the difference between the Expenditure(as % of GDP) in Kazakhstan in 2010 and the Expenditure(as % of GDP) in St. Vincent and the Grenadines in 2013?
Offer a terse response. -4.23. What is the difference between the Expenditure(as % of GDP) of Kazakhstan in 2010 and the Expenditure(as % of GDP) of Tunisia in 2013?
Your answer should be very brief. -4.73. What is the difference between the Expenditure(as % of GDP) of Sao Tome and Principe in 2010 and the Expenditure(as % of GDP) of St. Vincent and the Grenadines in 2013?
Ensure brevity in your answer.  -1.12. What is the difference between the Expenditure(as % of GDP) of Sao Tome and Principe in 2010 and the Expenditure(as % of GDP) of Tunisia in 2013?
Your response must be concise. -1.62. What is the difference between the Expenditure(as % of GDP) of St. Vincent and the Grenadines in 2010 and the Expenditure(as % of GDP) of Tunisia in 2013?
Your response must be concise. -0.62. What is the difference between the Expenditure(as % of GDP) of Kazakhstan in 2011 and the Expenditure(as % of GDP) of Sao Tome and Principe in 2012?
Offer a terse response. -2.3. What is the difference between the Expenditure(as % of GDP) in Kazakhstan in 2011 and the Expenditure(as % of GDP) in St. Vincent and the Grenadines in 2012?
Provide a succinct answer. -4.39. What is the difference between the Expenditure(as % of GDP) in Kazakhstan in 2011 and the Expenditure(as % of GDP) in Tunisia in 2012?
Your answer should be very brief. -4.92. What is the difference between the Expenditure(as % of GDP) of Sao Tome and Principe in 2011 and the Expenditure(as % of GDP) of St. Vincent and the Grenadines in 2012?
Keep it short and to the point. -1.62. What is the difference between the Expenditure(as % of GDP) of Sao Tome and Principe in 2011 and the Expenditure(as % of GDP) of Tunisia in 2012?
Provide a succinct answer. -2.15. What is the difference between the Expenditure(as % of GDP) of St. Vincent and the Grenadines in 2011 and the Expenditure(as % of GDP) of Tunisia in 2012?
Your answer should be very brief. -0.7. What is the difference between the Expenditure(as % of GDP) of Kazakhstan in 2011 and the Expenditure(as % of GDP) of Sao Tome and Principe in 2013?
Keep it short and to the point. -8.6. What is the difference between the Expenditure(as % of GDP) of Kazakhstan in 2011 and the Expenditure(as % of GDP) of St. Vincent and the Grenadines in 2013?
Give a very brief answer. -4.29. What is the difference between the Expenditure(as % of GDP) of Kazakhstan in 2011 and the Expenditure(as % of GDP) of Tunisia in 2013?
Make the answer very short. -4.79. What is the difference between the Expenditure(as % of GDP) of Sao Tome and Principe in 2011 and the Expenditure(as % of GDP) of St. Vincent and the Grenadines in 2013?
Make the answer very short. -1.52. What is the difference between the Expenditure(as % of GDP) in Sao Tome and Principe in 2011 and the Expenditure(as % of GDP) in Tunisia in 2013?
Give a very brief answer. -2.01. What is the difference between the Expenditure(as % of GDP) in St. Vincent and the Grenadines in 2011 and the Expenditure(as % of GDP) in Tunisia in 2013?
Offer a terse response. -0.56. What is the difference between the Expenditure(as % of GDP) of Kazakhstan in 2012 and the Expenditure(as % of GDP) of Sao Tome and Principe in 2013?
Give a very brief answer. -8.6. What is the difference between the Expenditure(as % of GDP) in Kazakhstan in 2012 and the Expenditure(as % of GDP) in St. Vincent and the Grenadines in 2013?
Offer a terse response. -4.3. What is the difference between the Expenditure(as % of GDP) of Kazakhstan in 2012 and the Expenditure(as % of GDP) of Tunisia in 2013?
Keep it short and to the point. -4.79. What is the difference between the Expenditure(as % of GDP) in Sao Tome and Principe in 2012 and the Expenditure(as % of GDP) in St. Vincent and the Grenadines in 2013?
Provide a short and direct response. -1.99. What is the difference between the Expenditure(as % of GDP) of Sao Tome and Principe in 2012 and the Expenditure(as % of GDP) of Tunisia in 2013?
Provide a short and direct response. -2.49. What is the difference between the Expenditure(as % of GDP) in St. Vincent and the Grenadines in 2012 and the Expenditure(as % of GDP) in Tunisia in 2013?
Make the answer very short. -0.39. What is the average Expenditure(as % of GDP) of Kazakhstan per year?
Provide a short and direct response. 0.12. What is the average Expenditure(as % of GDP) in Sao Tome and Principe per year?
Your response must be concise. 2.8. What is the average Expenditure(as % of GDP) in St. Vincent and the Grenadines per year?
Your answer should be very brief. 4.28. What is the average Expenditure(as % of GDP) of Tunisia per year?
Offer a very short reply. 4.59. In the year 2006, what is the difference between the Expenditure(as % of GDP) in Kazakhstan and Expenditure(as % of GDP) in Sao Tome and Principe?
Make the answer very short. -1.09. In the year 2006, what is the difference between the Expenditure(as % of GDP) in Kazakhstan and Expenditure(as % of GDP) in St. Vincent and the Grenadines?
Your answer should be very brief. -4.08. In the year 2006, what is the difference between the Expenditure(as % of GDP) in Kazakhstan and Expenditure(as % of GDP) in Tunisia?
Offer a terse response. -4.29. In the year 2006, what is the difference between the Expenditure(as % of GDP) in Sao Tome and Principe and Expenditure(as % of GDP) in St. Vincent and the Grenadines?
Ensure brevity in your answer.  -2.99. In the year 2006, what is the difference between the Expenditure(as % of GDP) of Sao Tome and Principe and Expenditure(as % of GDP) of Tunisia?
Your answer should be very brief. -3.2. In the year 2006, what is the difference between the Expenditure(as % of GDP) in St. Vincent and the Grenadines and Expenditure(as % of GDP) in Tunisia?
Give a very brief answer. -0.21. In the year 2007, what is the difference between the Expenditure(as % of GDP) in Kazakhstan and Expenditure(as % of GDP) in Sao Tome and Principe?
Your answer should be very brief. -1.24. In the year 2007, what is the difference between the Expenditure(as % of GDP) in Kazakhstan and Expenditure(as % of GDP) in St. Vincent and the Grenadines?
Your answer should be compact. -4.29. In the year 2007, what is the difference between the Expenditure(as % of GDP) of Kazakhstan and Expenditure(as % of GDP) of Tunisia?
Your answer should be very brief. -4.27. In the year 2007, what is the difference between the Expenditure(as % of GDP) in Sao Tome and Principe and Expenditure(as % of GDP) in St. Vincent and the Grenadines?
Offer a terse response. -3.06. In the year 2007, what is the difference between the Expenditure(as % of GDP) of Sao Tome and Principe and Expenditure(as % of GDP) of Tunisia?
Give a very brief answer. -3.04. In the year 2007, what is the difference between the Expenditure(as % of GDP) of St. Vincent and the Grenadines and Expenditure(as % of GDP) of Tunisia?
Make the answer very short. 0.02. In the year 2008, what is the difference between the Expenditure(as % of GDP) in Kazakhstan and Expenditure(as % of GDP) in Sao Tome and Principe?
Provide a succinct answer. -1.49. In the year 2008, what is the difference between the Expenditure(as % of GDP) in Kazakhstan and Expenditure(as % of GDP) in St. Vincent and the Grenadines?
Offer a very short reply. -3.76. In the year 2008, what is the difference between the Expenditure(as % of GDP) in Kazakhstan and Expenditure(as % of GDP) in Tunisia?
Ensure brevity in your answer.  -4.31. In the year 2008, what is the difference between the Expenditure(as % of GDP) of Sao Tome and Principe and Expenditure(as % of GDP) of St. Vincent and the Grenadines?
Provide a short and direct response. -2.27. In the year 2008, what is the difference between the Expenditure(as % of GDP) of Sao Tome and Principe and Expenditure(as % of GDP) of Tunisia?
Provide a short and direct response. -2.83. In the year 2008, what is the difference between the Expenditure(as % of GDP) of St. Vincent and the Grenadines and Expenditure(as % of GDP) of Tunisia?
Ensure brevity in your answer.  -0.56. In the year 2009, what is the difference between the Expenditure(as % of GDP) of Kazakhstan and Expenditure(as % of GDP) of Sao Tome and Principe?
Offer a terse response. -0.87. In the year 2009, what is the difference between the Expenditure(as % of GDP) in Kazakhstan and Expenditure(as % of GDP) in St. Vincent and the Grenadines?
Provide a short and direct response. -4.13. In the year 2009, what is the difference between the Expenditure(as % of GDP) of Kazakhstan and Expenditure(as % of GDP) of Tunisia?
Your answer should be compact. -4.35. In the year 2009, what is the difference between the Expenditure(as % of GDP) in Sao Tome and Principe and Expenditure(as % of GDP) in St. Vincent and the Grenadines?
Provide a succinct answer. -3.27. In the year 2009, what is the difference between the Expenditure(as % of GDP) in Sao Tome and Principe and Expenditure(as % of GDP) in Tunisia?
Give a very brief answer. -3.48. In the year 2009, what is the difference between the Expenditure(as % of GDP) in St. Vincent and the Grenadines and Expenditure(as % of GDP) in Tunisia?
Offer a very short reply. -0.22. In the year 2010, what is the difference between the Expenditure(as % of GDP) of Kazakhstan and Expenditure(as % of GDP) of Sao Tome and Principe?
Your response must be concise. -3.11. In the year 2010, what is the difference between the Expenditure(as % of GDP) in Kazakhstan and Expenditure(as % of GDP) in St. Vincent and the Grenadines?
Give a very brief answer. -4.11. In the year 2010, what is the difference between the Expenditure(as % of GDP) of Kazakhstan and Expenditure(as % of GDP) of Tunisia?
Your response must be concise. -4.53. In the year 2010, what is the difference between the Expenditure(as % of GDP) in Sao Tome and Principe and Expenditure(as % of GDP) in St. Vincent and the Grenadines?
Ensure brevity in your answer.  -1. In the year 2010, what is the difference between the Expenditure(as % of GDP) in Sao Tome and Principe and Expenditure(as % of GDP) in Tunisia?
Provide a succinct answer. -1.42. In the year 2010, what is the difference between the Expenditure(as % of GDP) in St. Vincent and the Grenadines and Expenditure(as % of GDP) in Tunisia?
Give a very brief answer. -0.42. In the year 2011, what is the difference between the Expenditure(as % of GDP) of Kazakhstan and Expenditure(as % of GDP) of Sao Tome and Principe?
Keep it short and to the point. -2.77. In the year 2011, what is the difference between the Expenditure(as % of GDP) of Kazakhstan and Expenditure(as % of GDP) of St. Vincent and the Grenadines?
Give a very brief answer. -4.23. In the year 2011, what is the difference between the Expenditure(as % of GDP) of Kazakhstan and Expenditure(as % of GDP) of Tunisia?
Ensure brevity in your answer.  -4.27. In the year 2011, what is the difference between the Expenditure(as % of GDP) of Sao Tome and Principe and Expenditure(as % of GDP) of St. Vincent and the Grenadines?
Offer a terse response. -1.46. In the year 2011, what is the difference between the Expenditure(as % of GDP) in Sao Tome and Principe and Expenditure(as % of GDP) in Tunisia?
Give a very brief answer. -1.5. In the year 2011, what is the difference between the Expenditure(as % of GDP) in St. Vincent and the Grenadines and Expenditure(as % of GDP) in Tunisia?
Offer a very short reply. -0.05. In the year 2012, what is the difference between the Expenditure(as % of GDP) in Kazakhstan and Expenditure(as % of GDP) in Sao Tome and Principe?
Your answer should be compact. -2.31. In the year 2012, what is the difference between the Expenditure(as % of GDP) in Kazakhstan and Expenditure(as % of GDP) in St. Vincent and the Grenadines?
Offer a terse response. -4.4. In the year 2012, what is the difference between the Expenditure(as % of GDP) in Kazakhstan and Expenditure(as % of GDP) in Tunisia?
Offer a terse response. -4.93. In the year 2012, what is the difference between the Expenditure(as % of GDP) of Sao Tome and Principe and Expenditure(as % of GDP) of St. Vincent and the Grenadines?
Offer a terse response. -2.1. In the year 2012, what is the difference between the Expenditure(as % of GDP) of Sao Tome and Principe and Expenditure(as % of GDP) of Tunisia?
Make the answer very short. -2.63. In the year 2012, what is the difference between the Expenditure(as % of GDP) in St. Vincent and the Grenadines and Expenditure(as % of GDP) in Tunisia?
Keep it short and to the point. -0.53. In the year 2013, what is the difference between the Expenditure(as % of GDP) of Kazakhstan and Expenditure(as % of GDP) of Sao Tome and Principe?
Ensure brevity in your answer.  -8.6. In the year 2013, what is the difference between the Expenditure(as % of GDP) of Kazakhstan and Expenditure(as % of GDP) of St. Vincent and the Grenadines?
Make the answer very short. -4.29. In the year 2013, what is the difference between the Expenditure(as % of GDP) in Kazakhstan and Expenditure(as % of GDP) in Tunisia?
Your response must be concise. -4.79. In the year 2013, what is the difference between the Expenditure(as % of GDP) in Sao Tome and Principe and Expenditure(as % of GDP) in St. Vincent and the Grenadines?
Keep it short and to the point. 4.31. In the year 2013, what is the difference between the Expenditure(as % of GDP) of Sao Tome and Principe and Expenditure(as % of GDP) of Tunisia?
Offer a terse response. 3.81. In the year 2013, what is the difference between the Expenditure(as % of GDP) of St. Vincent and the Grenadines and Expenditure(as % of GDP) of Tunisia?
Ensure brevity in your answer.  -0.5. What is the ratio of the Expenditure(as % of GDP) of Kazakhstan in 2006 to that in 2007?
Provide a short and direct response. 0.76. What is the ratio of the Expenditure(as % of GDP) of Sao Tome and Principe in 2006 to that in 2007?
Give a very brief answer. 0.87. What is the ratio of the Expenditure(as % of GDP) of St. Vincent and the Grenadines in 2006 to that in 2007?
Provide a short and direct response. 0.94. What is the ratio of the Expenditure(as % of GDP) of Kazakhstan in 2006 to that in 2008?
Keep it short and to the point. 1.1. What is the ratio of the Expenditure(as % of GDP) in Sao Tome and Principe in 2006 to that in 2008?
Keep it short and to the point. 0.75. What is the ratio of the Expenditure(as % of GDP) in St. Vincent and the Grenadines in 2006 to that in 2008?
Ensure brevity in your answer.  1.09. What is the ratio of the Expenditure(as % of GDP) of Kazakhstan in 2006 to that in 2009?
Your answer should be very brief. 0.6. What is the ratio of the Expenditure(as % of GDP) of Sao Tome and Principe in 2006 to that in 2009?
Offer a very short reply. 1.15. What is the ratio of the Expenditure(as % of GDP) of St. Vincent and the Grenadines in 2006 to that in 2009?
Your response must be concise. 0.97. What is the ratio of the Expenditure(as % of GDP) in Tunisia in 2006 to that in 2009?
Offer a terse response. 0.97. What is the ratio of the Expenditure(as % of GDP) of Kazakhstan in 2006 to that in 2010?
Make the answer very short. 0.68. What is the ratio of the Expenditure(as % of GDP) in Sao Tome and Principe in 2006 to that in 2010?
Your response must be concise. 0.36. What is the ratio of the Expenditure(as % of GDP) of St. Vincent and the Grenadines in 2006 to that in 2010?
Provide a short and direct response. 0.98. What is the ratio of the Expenditure(as % of GDP) in Tunisia in 2006 to that in 2010?
Provide a short and direct response. 0.94. What is the ratio of the Expenditure(as % of GDP) of Kazakhstan in 2006 to that in 2011?
Provide a succinct answer. 1.08. What is the ratio of the Expenditure(as % of GDP) of Sao Tome and Principe in 2006 to that in 2011?
Keep it short and to the point. 0.42. What is the ratio of the Expenditure(as % of GDP) in Tunisia in 2006 to that in 2011?
Your answer should be very brief. 1.01. What is the ratio of the Expenditure(as % of GDP) of Kazakhstan in 2006 to that in 2012?
Make the answer very short. 1.18. What is the ratio of the Expenditure(as % of GDP) in Sao Tome and Principe in 2006 to that in 2012?
Offer a terse response. 0.5. What is the ratio of the Expenditure(as % of GDP) in St. Vincent and the Grenadines in 2006 to that in 2012?
Your answer should be compact. 0.93. What is the ratio of the Expenditure(as % of GDP) in Tunisia in 2006 to that in 2012?
Offer a terse response. 0.87. What is the ratio of the Expenditure(as % of GDP) in Kazakhstan in 2006 to that in 2013?
Offer a terse response. 1.16. What is the ratio of the Expenditure(as % of GDP) of Sao Tome and Principe in 2006 to that in 2013?
Your answer should be very brief. 0.14. What is the ratio of the Expenditure(as % of GDP) of St. Vincent and the Grenadines in 2006 to that in 2013?
Your answer should be compact. 0.95. What is the ratio of the Expenditure(as % of GDP) of Tunisia in 2006 to that in 2013?
Provide a succinct answer. 0.9. What is the ratio of the Expenditure(as % of GDP) in Kazakhstan in 2007 to that in 2008?
Give a very brief answer. 1.45. What is the ratio of the Expenditure(as % of GDP) in Sao Tome and Principe in 2007 to that in 2008?
Provide a short and direct response. 0.87. What is the ratio of the Expenditure(as % of GDP) of St. Vincent and the Grenadines in 2007 to that in 2008?
Make the answer very short. 1.15. What is the ratio of the Expenditure(as % of GDP) of Kazakhstan in 2007 to that in 2009?
Your answer should be very brief. 0.79. What is the ratio of the Expenditure(as % of GDP) in Sao Tome and Principe in 2007 to that in 2009?
Keep it short and to the point. 1.32. What is the ratio of the Expenditure(as % of GDP) of St. Vincent and the Grenadines in 2007 to that in 2009?
Give a very brief answer. 1.03. What is the ratio of the Expenditure(as % of GDP) of Tunisia in 2007 to that in 2009?
Give a very brief answer. 0.98. What is the ratio of the Expenditure(as % of GDP) in Kazakhstan in 2007 to that in 2010?
Make the answer very short. 0.9. What is the ratio of the Expenditure(as % of GDP) of Sao Tome and Principe in 2007 to that in 2010?
Your answer should be compact. 0.42. What is the ratio of the Expenditure(as % of GDP) in St. Vincent and the Grenadines in 2007 to that in 2010?
Ensure brevity in your answer.  1.04. What is the ratio of the Expenditure(as % of GDP) in Tunisia in 2007 to that in 2010?
Offer a terse response. 0.94. What is the ratio of the Expenditure(as % of GDP) of Kazakhstan in 2007 to that in 2011?
Provide a succinct answer. 1.43. What is the ratio of the Expenditure(as % of GDP) in Sao Tome and Principe in 2007 to that in 2011?
Give a very brief answer. 0.48. What is the ratio of the Expenditure(as % of GDP) in St. Vincent and the Grenadines in 2007 to that in 2011?
Give a very brief answer. 1.02. What is the ratio of the Expenditure(as % of GDP) in Tunisia in 2007 to that in 2011?
Your answer should be very brief. 1.01. What is the ratio of the Expenditure(as % of GDP) of Kazakhstan in 2007 to that in 2012?
Offer a terse response. 1.56. What is the ratio of the Expenditure(as % of GDP) of Sao Tome and Principe in 2007 to that in 2012?
Keep it short and to the point. 0.57. What is the ratio of the Expenditure(as % of GDP) of Tunisia in 2007 to that in 2012?
Offer a very short reply. 0.88. What is the ratio of the Expenditure(as % of GDP) in Kazakhstan in 2007 to that in 2013?
Provide a short and direct response. 1.53. What is the ratio of the Expenditure(as % of GDP) of Sao Tome and Principe in 2007 to that in 2013?
Provide a short and direct response. 0.16. What is the ratio of the Expenditure(as % of GDP) in St. Vincent and the Grenadines in 2007 to that in 2013?
Make the answer very short. 1.01. What is the ratio of the Expenditure(as % of GDP) of Tunisia in 2007 to that in 2013?
Provide a succinct answer. 0.9. What is the ratio of the Expenditure(as % of GDP) of Kazakhstan in 2008 to that in 2009?
Offer a very short reply. 0.55. What is the ratio of the Expenditure(as % of GDP) in Sao Tome and Principe in 2008 to that in 2009?
Give a very brief answer. 1.52. What is the ratio of the Expenditure(as % of GDP) of St. Vincent and the Grenadines in 2008 to that in 2009?
Make the answer very short. 0.89. What is the ratio of the Expenditure(as % of GDP) in Tunisia in 2008 to that in 2009?
Your answer should be very brief. 0.97. What is the ratio of the Expenditure(as % of GDP) in Kazakhstan in 2008 to that in 2010?
Make the answer very short. 0.62. What is the ratio of the Expenditure(as % of GDP) of Sao Tome and Principe in 2008 to that in 2010?
Make the answer very short. 0.49. What is the ratio of the Expenditure(as % of GDP) of St. Vincent and the Grenadines in 2008 to that in 2010?
Ensure brevity in your answer.  0.9. What is the ratio of the Expenditure(as % of GDP) of Tunisia in 2008 to that in 2010?
Your answer should be compact. 0.94. What is the ratio of the Expenditure(as % of GDP) in Kazakhstan in 2008 to that in 2011?
Provide a short and direct response. 0.98. What is the ratio of the Expenditure(as % of GDP) of Sao Tome and Principe in 2008 to that in 2011?
Provide a short and direct response. 0.55. What is the ratio of the Expenditure(as % of GDP) in St. Vincent and the Grenadines in 2008 to that in 2011?
Provide a succinct answer. 0.89. What is the ratio of the Expenditure(as % of GDP) of Tunisia in 2008 to that in 2011?
Give a very brief answer. 1.01. What is the ratio of the Expenditure(as % of GDP) in Kazakhstan in 2008 to that in 2012?
Offer a very short reply. 1.08. What is the ratio of the Expenditure(as % of GDP) in Sao Tome and Principe in 2008 to that in 2012?
Give a very brief answer. 0.66. What is the ratio of the Expenditure(as % of GDP) of St. Vincent and the Grenadines in 2008 to that in 2012?
Provide a succinct answer. 0.86. What is the ratio of the Expenditure(as % of GDP) of Tunisia in 2008 to that in 2012?
Your answer should be compact. 0.88. What is the ratio of the Expenditure(as % of GDP) in Kazakhstan in 2008 to that in 2013?
Provide a short and direct response. 1.05. What is the ratio of the Expenditure(as % of GDP) in Sao Tome and Principe in 2008 to that in 2013?
Your answer should be compact. 0.18. What is the ratio of the Expenditure(as % of GDP) of St. Vincent and the Grenadines in 2008 to that in 2013?
Ensure brevity in your answer.  0.88. What is the ratio of the Expenditure(as % of GDP) in Tunisia in 2008 to that in 2013?
Give a very brief answer. 0.9. What is the ratio of the Expenditure(as % of GDP) of Kazakhstan in 2009 to that in 2010?
Your response must be concise. 1.13. What is the ratio of the Expenditure(as % of GDP) in Sao Tome and Principe in 2009 to that in 2010?
Offer a terse response. 0.32. What is the ratio of the Expenditure(as % of GDP) of St. Vincent and the Grenadines in 2009 to that in 2010?
Your answer should be compact. 1.01. What is the ratio of the Expenditure(as % of GDP) of Tunisia in 2009 to that in 2010?
Provide a short and direct response. 0.97. What is the ratio of the Expenditure(as % of GDP) in Kazakhstan in 2009 to that in 2011?
Your answer should be compact. 1.8. What is the ratio of the Expenditure(as % of GDP) in Sao Tome and Principe in 2009 to that in 2011?
Offer a terse response. 0.36. What is the ratio of the Expenditure(as % of GDP) of St. Vincent and the Grenadines in 2009 to that in 2011?
Provide a short and direct response. 1. What is the ratio of the Expenditure(as % of GDP) of Tunisia in 2009 to that in 2011?
Offer a terse response. 1.03. What is the ratio of the Expenditure(as % of GDP) in Kazakhstan in 2009 to that in 2012?
Your answer should be very brief. 1.96. What is the ratio of the Expenditure(as % of GDP) in Sao Tome and Principe in 2009 to that in 2012?
Make the answer very short. 0.43. What is the ratio of the Expenditure(as % of GDP) of Tunisia in 2009 to that in 2012?
Ensure brevity in your answer.  0.9. What is the ratio of the Expenditure(as % of GDP) of Kazakhstan in 2009 to that in 2013?
Ensure brevity in your answer.  1.93. What is the ratio of the Expenditure(as % of GDP) in Sao Tome and Principe in 2009 to that in 2013?
Offer a terse response. 0.12. What is the ratio of the Expenditure(as % of GDP) of St. Vincent and the Grenadines in 2009 to that in 2013?
Provide a short and direct response. 0.98. What is the ratio of the Expenditure(as % of GDP) in Tunisia in 2009 to that in 2013?
Offer a terse response. 0.93. What is the ratio of the Expenditure(as % of GDP) in Kazakhstan in 2010 to that in 2011?
Keep it short and to the point. 1.59. What is the ratio of the Expenditure(as % of GDP) of Sao Tome and Principe in 2010 to that in 2011?
Provide a short and direct response. 1.14. What is the ratio of the Expenditure(as % of GDP) of St. Vincent and the Grenadines in 2010 to that in 2011?
Ensure brevity in your answer.  0.99. What is the ratio of the Expenditure(as % of GDP) of Tunisia in 2010 to that in 2011?
Provide a short and direct response. 1.07. What is the ratio of the Expenditure(as % of GDP) in Kazakhstan in 2010 to that in 2012?
Your answer should be compact. 1.74. What is the ratio of the Expenditure(as % of GDP) in Sao Tome and Principe in 2010 to that in 2012?
Ensure brevity in your answer.  1.36. What is the ratio of the Expenditure(as % of GDP) of Tunisia in 2010 to that in 2012?
Your answer should be compact. 0.93. What is the ratio of the Expenditure(as % of GDP) of Kazakhstan in 2010 to that in 2013?
Offer a terse response. 1.71. What is the ratio of the Expenditure(as % of GDP) of Sao Tome and Principe in 2010 to that in 2013?
Ensure brevity in your answer.  0.38. What is the ratio of the Expenditure(as % of GDP) of St. Vincent and the Grenadines in 2010 to that in 2013?
Your response must be concise. 0.97. What is the ratio of the Expenditure(as % of GDP) of Tunisia in 2010 to that in 2013?
Provide a succinct answer. 0.96. What is the ratio of the Expenditure(as % of GDP) in Kazakhstan in 2011 to that in 2012?
Your answer should be very brief. 1.09. What is the ratio of the Expenditure(as % of GDP) in Sao Tome and Principe in 2011 to that in 2012?
Offer a terse response. 1.2. What is the ratio of the Expenditure(as % of GDP) of St. Vincent and the Grenadines in 2011 to that in 2012?
Keep it short and to the point. 0.96. What is the ratio of the Expenditure(as % of GDP) of Tunisia in 2011 to that in 2012?
Provide a succinct answer. 0.87. What is the ratio of the Expenditure(as % of GDP) in Kazakhstan in 2011 to that in 2013?
Provide a short and direct response. 1.07. What is the ratio of the Expenditure(as % of GDP) in Sao Tome and Principe in 2011 to that in 2013?
Your answer should be very brief. 0.33. What is the ratio of the Expenditure(as % of GDP) of St. Vincent and the Grenadines in 2011 to that in 2013?
Your answer should be compact. 0.99. What is the ratio of the Expenditure(as % of GDP) of Tunisia in 2011 to that in 2013?
Provide a succinct answer. 0.9. What is the ratio of the Expenditure(as % of GDP) in Kazakhstan in 2012 to that in 2013?
Make the answer very short. 0.98. What is the ratio of the Expenditure(as % of GDP) of Sao Tome and Principe in 2012 to that in 2013?
Keep it short and to the point. 0.28. What is the ratio of the Expenditure(as % of GDP) of St. Vincent and the Grenadines in 2012 to that in 2013?
Provide a short and direct response. 1.02. What is the ratio of the Expenditure(as % of GDP) of Tunisia in 2012 to that in 2013?
Your response must be concise. 1.03. What is the difference between the highest and the second highest Expenditure(as % of GDP) in Kazakhstan?
Provide a succinct answer. 0.02. What is the difference between the highest and the second highest Expenditure(as % of GDP) of Sao Tome and Principe?
Keep it short and to the point. 5.43. What is the difference between the highest and the second highest Expenditure(as % of GDP) of St. Vincent and the Grenadines?
Provide a succinct answer. 0.06. What is the difference between the highest and the second highest Expenditure(as % of GDP) in Tunisia?
Provide a short and direct response. 0.14. What is the difference between the highest and the lowest Expenditure(as % of GDP) of Kazakhstan?
Your answer should be very brief. 0.08. What is the difference between the highest and the lowest Expenditure(as % of GDP) in Sao Tome and Principe?
Offer a very short reply. 7.65. What is the difference between the highest and the lowest Expenditure(as % of GDP) in St. Vincent and the Grenadines?
Ensure brevity in your answer.  0.64. What is the difference between the highest and the lowest Expenditure(as % of GDP) of Tunisia?
Your response must be concise. 0.65. 